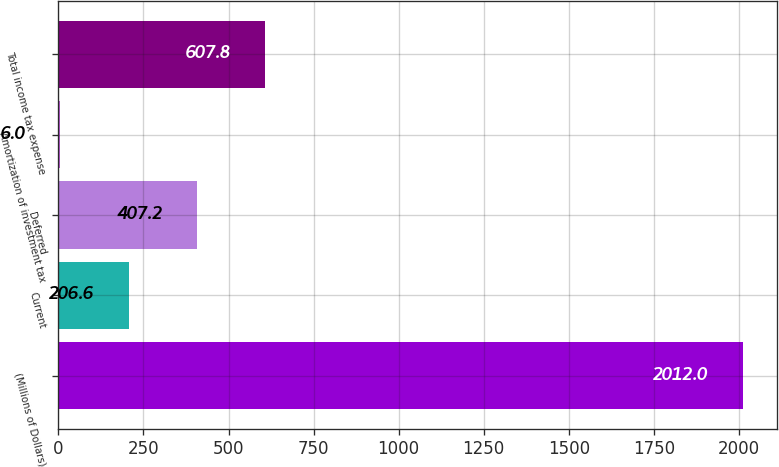<chart> <loc_0><loc_0><loc_500><loc_500><bar_chart><fcel>(Millions of Dollars)<fcel>Current<fcel>Deferred<fcel>Amortization of investment tax<fcel>Total income tax expense<nl><fcel>2012<fcel>206.6<fcel>407.2<fcel>6<fcel>607.8<nl></chart> 